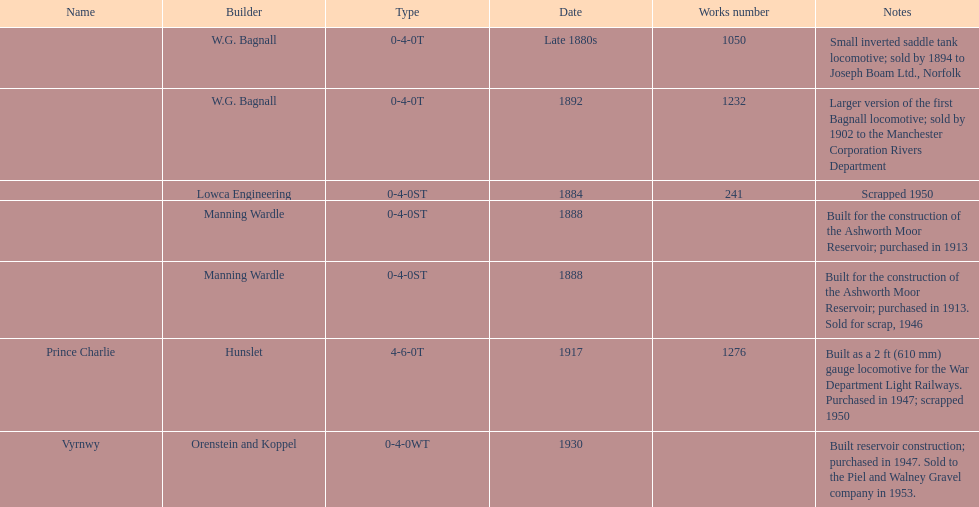How many locomotives were scrapped? 3. 